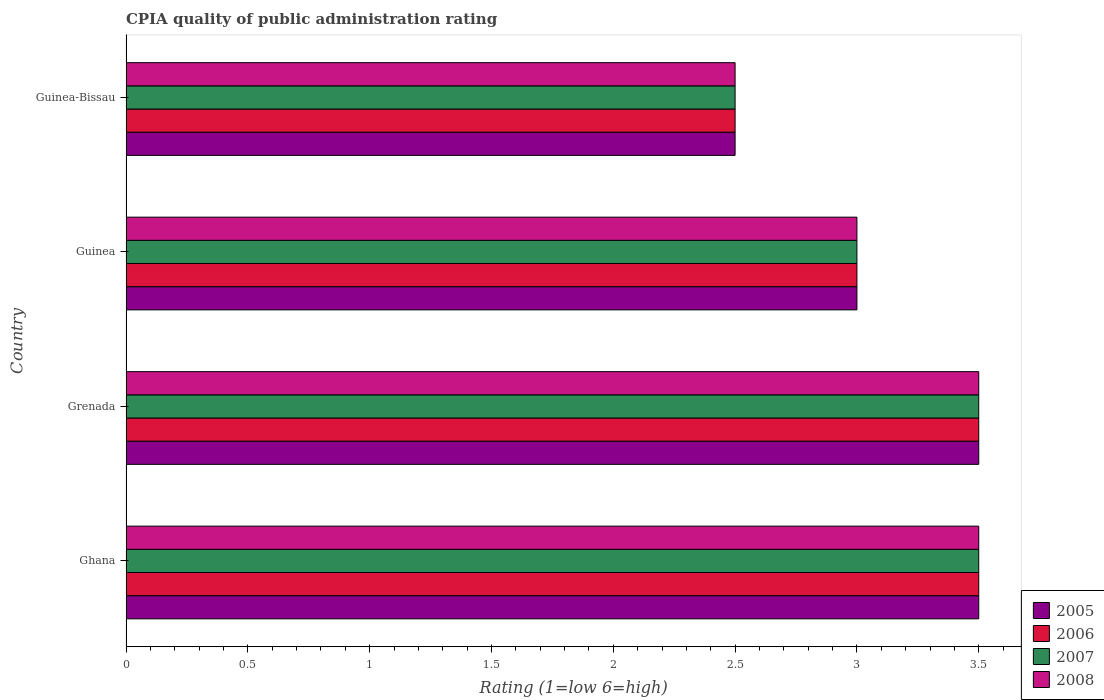How many groups of bars are there?
Make the answer very short. 4. Are the number of bars on each tick of the Y-axis equal?
Your response must be concise. Yes. How many bars are there on the 4th tick from the bottom?
Your answer should be compact. 4. What is the label of the 4th group of bars from the top?
Make the answer very short. Ghana. In how many cases, is the number of bars for a given country not equal to the number of legend labels?
Give a very brief answer. 0. Across all countries, what is the maximum CPIA rating in 2005?
Make the answer very short. 3.5. In which country was the CPIA rating in 2006 maximum?
Your response must be concise. Ghana. In which country was the CPIA rating in 2005 minimum?
Your response must be concise. Guinea-Bissau. What is the difference between the CPIA rating in 2007 in Ghana and that in Guinea-Bissau?
Offer a very short reply. 1. What is the difference between the CPIA rating in 2006 in Guinea-Bissau and the CPIA rating in 2007 in Grenada?
Offer a very short reply. -1. What is the average CPIA rating in 2007 per country?
Offer a very short reply. 3.12. What is the difference between the CPIA rating in 2007 and CPIA rating in 2006 in Grenada?
Keep it short and to the point. 0. What is the ratio of the CPIA rating in 2006 in Ghana to that in Guinea?
Your answer should be compact. 1.17. Is the difference between the CPIA rating in 2007 in Ghana and Grenada greater than the difference between the CPIA rating in 2006 in Ghana and Grenada?
Your answer should be very brief. No. In how many countries, is the CPIA rating in 2008 greater than the average CPIA rating in 2008 taken over all countries?
Provide a succinct answer. 2. Is the sum of the CPIA rating in 2005 in Grenada and Guinea greater than the maximum CPIA rating in 2007 across all countries?
Your answer should be compact. Yes. How many bars are there?
Give a very brief answer. 16. Are all the bars in the graph horizontal?
Ensure brevity in your answer.  Yes. How many countries are there in the graph?
Give a very brief answer. 4. What is the difference between two consecutive major ticks on the X-axis?
Give a very brief answer. 0.5. Are the values on the major ticks of X-axis written in scientific E-notation?
Provide a short and direct response. No. Does the graph contain any zero values?
Give a very brief answer. No. Does the graph contain grids?
Keep it short and to the point. No. Where does the legend appear in the graph?
Your answer should be compact. Bottom right. How many legend labels are there?
Keep it short and to the point. 4. What is the title of the graph?
Your answer should be compact. CPIA quality of public administration rating. Does "1988" appear as one of the legend labels in the graph?
Your answer should be very brief. No. What is the label or title of the X-axis?
Provide a short and direct response. Rating (1=low 6=high). What is the Rating (1=low 6=high) of 2005 in Ghana?
Make the answer very short. 3.5. What is the Rating (1=low 6=high) of 2008 in Ghana?
Make the answer very short. 3.5. What is the Rating (1=low 6=high) of 2005 in Grenada?
Give a very brief answer. 3.5. What is the Rating (1=low 6=high) of 2006 in Grenada?
Provide a succinct answer. 3.5. What is the Rating (1=low 6=high) in 2005 in Guinea?
Give a very brief answer. 3. What is the Rating (1=low 6=high) in 2006 in Guinea-Bissau?
Provide a succinct answer. 2.5. Across all countries, what is the maximum Rating (1=low 6=high) of 2005?
Offer a terse response. 3.5. Across all countries, what is the maximum Rating (1=low 6=high) of 2006?
Your answer should be very brief. 3.5. Across all countries, what is the maximum Rating (1=low 6=high) of 2007?
Provide a short and direct response. 3.5. Across all countries, what is the minimum Rating (1=low 6=high) of 2008?
Keep it short and to the point. 2.5. What is the total Rating (1=low 6=high) of 2005 in the graph?
Give a very brief answer. 12.5. What is the total Rating (1=low 6=high) of 2008 in the graph?
Give a very brief answer. 12.5. What is the difference between the Rating (1=low 6=high) in 2005 in Ghana and that in Grenada?
Keep it short and to the point. 0. What is the difference between the Rating (1=low 6=high) of 2006 in Ghana and that in Grenada?
Provide a short and direct response. 0. What is the difference between the Rating (1=low 6=high) of 2008 in Ghana and that in Grenada?
Offer a terse response. 0. What is the difference between the Rating (1=low 6=high) of 2005 in Ghana and that in Guinea?
Your answer should be compact. 0.5. What is the difference between the Rating (1=low 6=high) of 2006 in Ghana and that in Guinea?
Your answer should be very brief. 0.5. What is the difference between the Rating (1=low 6=high) of 2007 in Ghana and that in Guinea?
Keep it short and to the point. 0.5. What is the difference between the Rating (1=low 6=high) in 2005 in Ghana and that in Guinea-Bissau?
Offer a terse response. 1. What is the difference between the Rating (1=low 6=high) of 2007 in Ghana and that in Guinea-Bissau?
Provide a succinct answer. 1. What is the difference between the Rating (1=low 6=high) of 2008 in Ghana and that in Guinea-Bissau?
Make the answer very short. 1. What is the difference between the Rating (1=low 6=high) of 2006 in Grenada and that in Guinea?
Provide a short and direct response. 0.5. What is the difference between the Rating (1=low 6=high) in 2008 in Grenada and that in Guinea?
Provide a succinct answer. 0.5. What is the difference between the Rating (1=low 6=high) in 2006 in Grenada and that in Guinea-Bissau?
Ensure brevity in your answer.  1. What is the difference between the Rating (1=low 6=high) of 2007 in Grenada and that in Guinea-Bissau?
Ensure brevity in your answer.  1. What is the difference between the Rating (1=low 6=high) of 2006 in Guinea and that in Guinea-Bissau?
Your answer should be compact. 0.5. What is the difference between the Rating (1=low 6=high) of 2008 in Guinea and that in Guinea-Bissau?
Give a very brief answer. 0.5. What is the difference between the Rating (1=low 6=high) in 2005 in Ghana and the Rating (1=low 6=high) in 2006 in Grenada?
Offer a very short reply. 0. What is the difference between the Rating (1=low 6=high) in 2005 in Ghana and the Rating (1=low 6=high) in 2008 in Grenada?
Provide a short and direct response. 0. What is the difference between the Rating (1=low 6=high) in 2006 in Ghana and the Rating (1=low 6=high) in 2007 in Grenada?
Provide a short and direct response. 0. What is the difference between the Rating (1=low 6=high) in 2006 in Ghana and the Rating (1=low 6=high) in 2008 in Grenada?
Give a very brief answer. 0. What is the difference between the Rating (1=low 6=high) in 2007 in Ghana and the Rating (1=low 6=high) in 2008 in Grenada?
Your response must be concise. 0. What is the difference between the Rating (1=low 6=high) of 2005 in Ghana and the Rating (1=low 6=high) of 2006 in Guinea?
Ensure brevity in your answer.  0.5. What is the difference between the Rating (1=low 6=high) of 2005 in Ghana and the Rating (1=low 6=high) of 2008 in Guinea?
Provide a short and direct response. 0.5. What is the difference between the Rating (1=low 6=high) of 2005 in Ghana and the Rating (1=low 6=high) of 2006 in Guinea-Bissau?
Offer a terse response. 1. What is the difference between the Rating (1=low 6=high) of 2005 in Ghana and the Rating (1=low 6=high) of 2007 in Guinea-Bissau?
Give a very brief answer. 1. What is the difference between the Rating (1=low 6=high) of 2006 in Ghana and the Rating (1=low 6=high) of 2008 in Guinea-Bissau?
Your response must be concise. 1. What is the difference between the Rating (1=low 6=high) in 2007 in Ghana and the Rating (1=low 6=high) in 2008 in Guinea-Bissau?
Give a very brief answer. 1. What is the difference between the Rating (1=low 6=high) in 2005 in Grenada and the Rating (1=low 6=high) in 2006 in Guinea?
Offer a very short reply. 0.5. What is the difference between the Rating (1=low 6=high) of 2005 in Grenada and the Rating (1=low 6=high) of 2007 in Guinea?
Ensure brevity in your answer.  0.5. What is the difference between the Rating (1=low 6=high) of 2006 in Grenada and the Rating (1=low 6=high) of 2008 in Guinea?
Your answer should be very brief. 0.5. What is the difference between the Rating (1=low 6=high) of 2005 in Grenada and the Rating (1=low 6=high) of 2006 in Guinea-Bissau?
Keep it short and to the point. 1. What is the difference between the Rating (1=low 6=high) of 2005 in Grenada and the Rating (1=low 6=high) of 2008 in Guinea-Bissau?
Give a very brief answer. 1. What is the difference between the Rating (1=low 6=high) of 2006 in Grenada and the Rating (1=low 6=high) of 2007 in Guinea-Bissau?
Provide a short and direct response. 1. What is the difference between the Rating (1=low 6=high) in 2006 in Grenada and the Rating (1=low 6=high) in 2008 in Guinea-Bissau?
Ensure brevity in your answer.  1. What is the difference between the Rating (1=low 6=high) in 2007 in Grenada and the Rating (1=low 6=high) in 2008 in Guinea-Bissau?
Your response must be concise. 1. What is the difference between the Rating (1=low 6=high) of 2005 in Guinea and the Rating (1=low 6=high) of 2006 in Guinea-Bissau?
Make the answer very short. 0.5. What is the difference between the Rating (1=low 6=high) of 2005 in Guinea and the Rating (1=low 6=high) of 2007 in Guinea-Bissau?
Keep it short and to the point. 0.5. What is the difference between the Rating (1=low 6=high) in 2006 in Guinea and the Rating (1=low 6=high) in 2007 in Guinea-Bissau?
Provide a succinct answer. 0.5. What is the difference between the Rating (1=low 6=high) of 2007 in Guinea and the Rating (1=low 6=high) of 2008 in Guinea-Bissau?
Your answer should be compact. 0.5. What is the average Rating (1=low 6=high) in 2005 per country?
Give a very brief answer. 3.12. What is the average Rating (1=low 6=high) of 2006 per country?
Offer a very short reply. 3.12. What is the average Rating (1=low 6=high) of 2007 per country?
Keep it short and to the point. 3.12. What is the average Rating (1=low 6=high) in 2008 per country?
Give a very brief answer. 3.12. What is the difference between the Rating (1=low 6=high) of 2005 and Rating (1=low 6=high) of 2007 in Ghana?
Your answer should be very brief. 0. What is the difference between the Rating (1=low 6=high) in 2005 and Rating (1=low 6=high) in 2008 in Ghana?
Offer a terse response. 0. What is the difference between the Rating (1=low 6=high) of 2006 and Rating (1=low 6=high) of 2007 in Ghana?
Your answer should be very brief. 0. What is the difference between the Rating (1=low 6=high) in 2006 and Rating (1=low 6=high) in 2008 in Ghana?
Give a very brief answer. 0. What is the difference between the Rating (1=low 6=high) in 2005 and Rating (1=low 6=high) in 2008 in Grenada?
Your answer should be compact. 0. What is the difference between the Rating (1=low 6=high) of 2006 and Rating (1=low 6=high) of 2007 in Grenada?
Your answer should be very brief. 0. What is the difference between the Rating (1=low 6=high) of 2006 and Rating (1=low 6=high) of 2008 in Grenada?
Give a very brief answer. 0. What is the difference between the Rating (1=low 6=high) in 2005 and Rating (1=low 6=high) in 2006 in Guinea?
Ensure brevity in your answer.  0. What is the difference between the Rating (1=low 6=high) in 2005 and Rating (1=low 6=high) in 2008 in Guinea?
Provide a succinct answer. 0. What is the difference between the Rating (1=low 6=high) of 2006 and Rating (1=low 6=high) of 2008 in Guinea?
Offer a very short reply. 0. What is the difference between the Rating (1=low 6=high) of 2005 and Rating (1=low 6=high) of 2006 in Guinea-Bissau?
Your answer should be compact. 0. What is the difference between the Rating (1=low 6=high) in 2006 and Rating (1=low 6=high) in 2008 in Guinea-Bissau?
Provide a succinct answer. 0. What is the ratio of the Rating (1=low 6=high) of 2006 in Ghana to that in Guinea?
Ensure brevity in your answer.  1.17. What is the ratio of the Rating (1=low 6=high) in 2007 in Ghana to that in Guinea?
Your answer should be very brief. 1.17. What is the ratio of the Rating (1=low 6=high) in 2008 in Ghana to that in Guinea?
Offer a very short reply. 1.17. What is the ratio of the Rating (1=low 6=high) of 2005 in Ghana to that in Guinea-Bissau?
Make the answer very short. 1.4. What is the ratio of the Rating (1=low 6=high) in 2006 in Ghana to that in Guinea-Bissau?
Offer a very short reply. 1.4. What is the ratio of the Rating (1=low 6=high) in 2007 in Ghana to that in Guinea-Bissau?
Make the answer very short. 1.4. What is the ratio of the Rating (1=low 6=high) of 2006 in Grenada to that in Guinea?
Offer a terse response. 1.17. What is the ratio of the Rating (1=low 6=high) of 2007 in Grenada to that in Guinea?
Make the answer very short. 1.17. What is the ratio of the Rating (1=low 6=high) in 2008 in Grenada to that in Guinea?
Provide a succinct answer. 1.17. What is the ratio of the Rating (1=low 6=high) of 2005 in Grenada to that in Guinea-Bissau?
Give a very brief answer. 1.4. What is the ratio of the Rating (1=low 6=high) of 2007 in Grenada to that in Guinea-Bissau?
Offer a very short reply. 1.4. What is the ratio of the Rating (1=low 6=high) in 2005 in Guinea to that in Guinea-Bissau?
Offer a terse response. 1.2. What is the ratio of the Rating (1=low 6=high) of 2008 in Guinea to that in Guinea-Bissau?
Your response must be concise. 1.2. What is the difference between the highest and the second highest Rating (1=low 6=high) of 2005?
Ensure brevity in your answer.  0. What is the difference between the highest and the lowest Rating (1=low 6=high) of 2006?
Provide a succinct answer. 1. What is the difference between the highest and the lowest Rating (1=low 6=high) of 2007?
Your response must be concise. 1. 